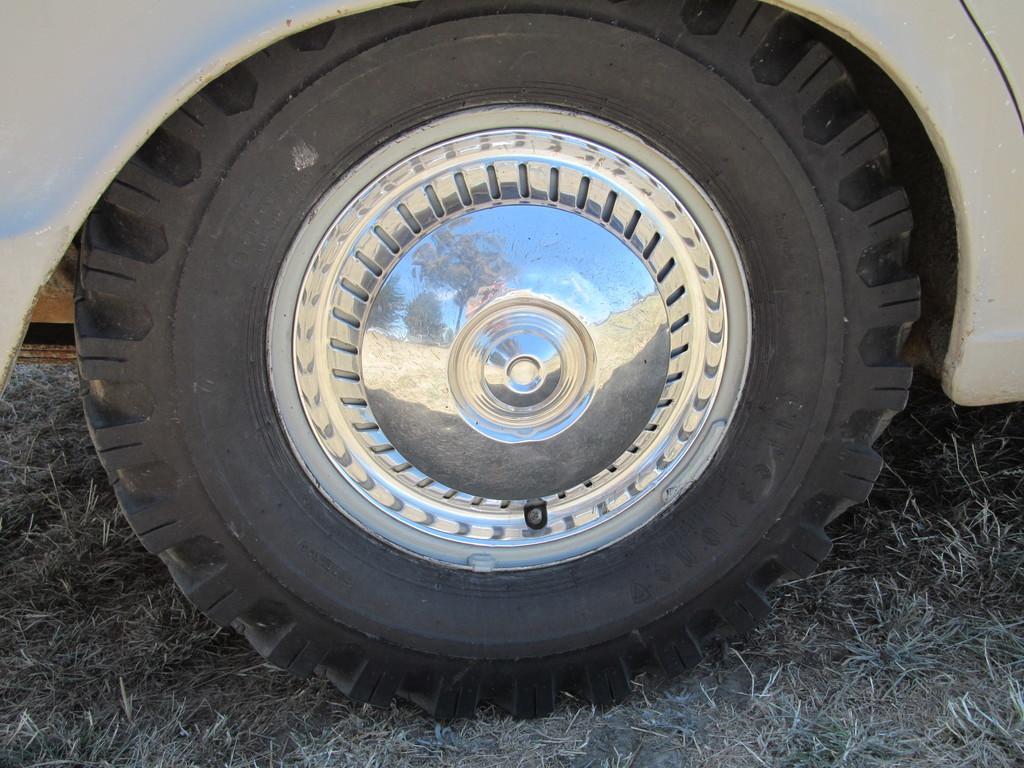In one or two sentences, can you explain what this image depicts? In this image I can see a wheel of a vehicle. There is a tyre and a centre cap. 